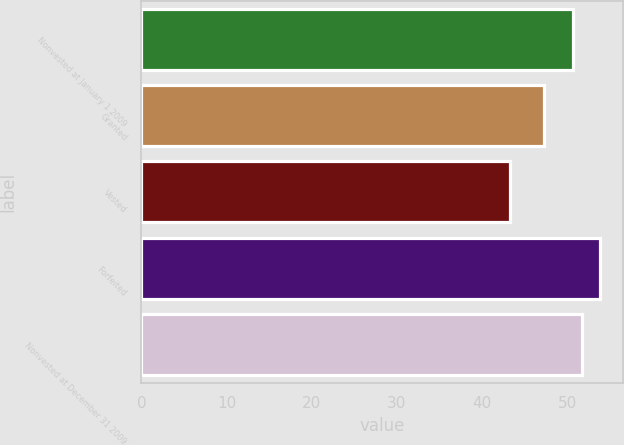<chart> <loc_0><loc_0><loc_500><loc_500><bar_chart><fcel>Nonvested at January 1 2009<fcel>Granted<fcel>Vested<fcel>Forfeited<fcel>Nonvested at December 31 2009<nl><fcel>50.7<fcel>47.28<fcel>43.23<fcel>53.86<fcel>51.76<nl></chart> 